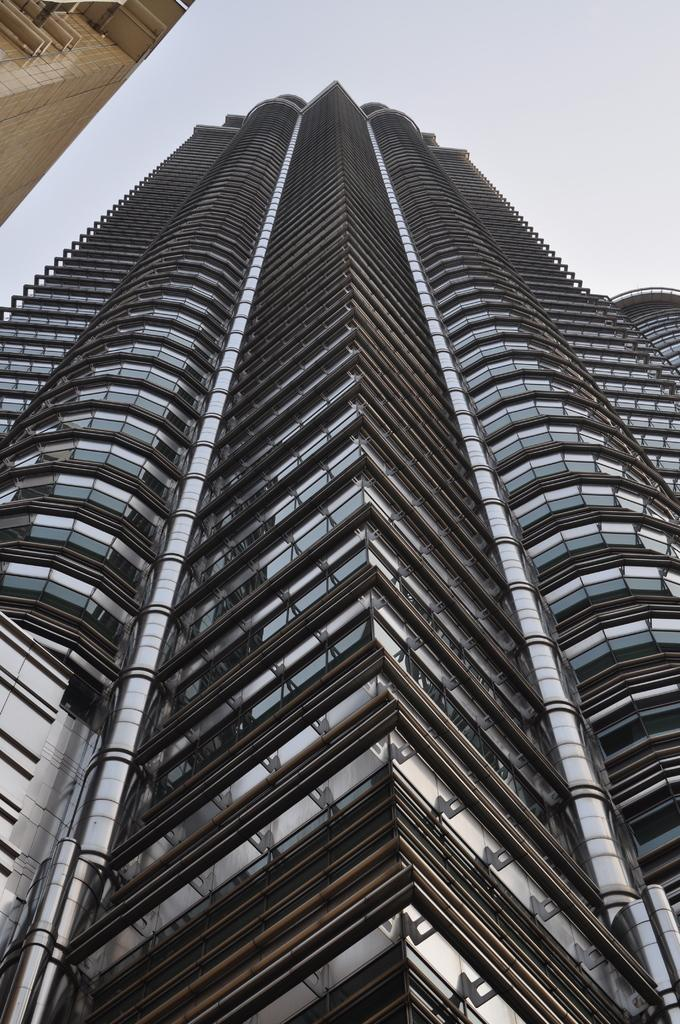What type of structures can be seen in the image? There are buildings in the image. What is visible at the top of the image? The sky is visible at the top of the image. What type of toy can be seen in the image? There is no toy present in the image. How much sugar is visible in the image? There is no sugar present in the image. 